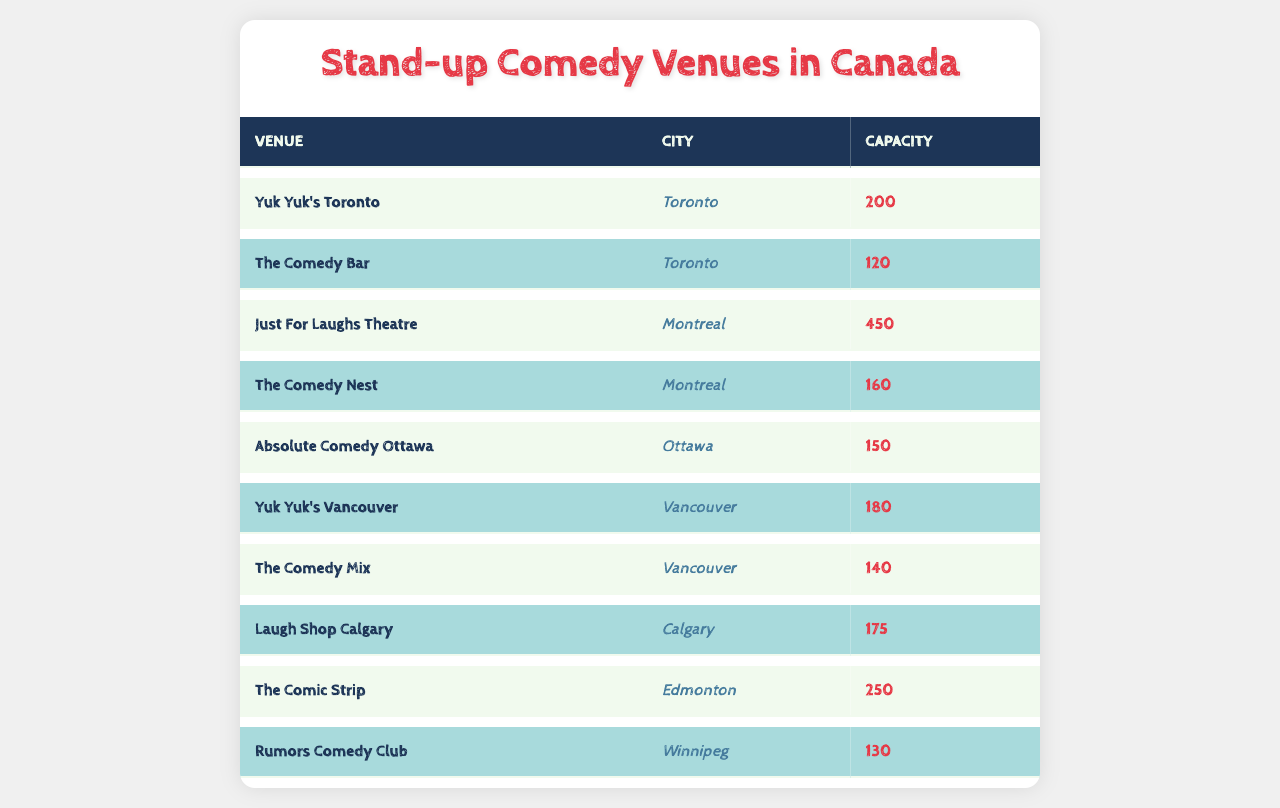What is the capacity of Yuk Yuk's Toronto? The table lists Yuk Yuk's Toronto, where the corresponding capacity is directly provided as 200.
Answer: 200 How many venues are located in Montreal? The table shows two venues in Montreal: Just For Laughs Theatre and The Comedy Nest. Therefore, the total count is 2.
Answer: 2 Which venue has the largest capacity? By examining the capacities listed, Just For Laughs Theatre has the largest capacity at 450, which is greater than any other venue.
Answer: 450 Is the capacity of the Comedy Mix greater than 150? The capacity of the Comedy Mix is listed as 140, which is less than 150, making the statement false.
Answer: No What is the total capacity of all venues in Vancouver? The capacities for the Vancouver venues are Yuk Yuk's Vancouver (180) and The Comedy Mix (140). Adding these gives: 180 + 140 = 320.
Answer: 320 Which city has the venue with the least capacity? The venue with the least capacity is The Comedy Mix (140) located in Vancouver. Since we are comparing all venues, it identifies Vancouver as having the smallest venue.
Answer: Vancouver What is the average capacity of all venues in the table? To find the average, add the capacities of all venues (200 + 120 + 450 + 160 + 150 + 180 + 140 + 175 + 250 + 130 = 1955) and then divide by the number of venues (10). Thus, the average is 1955 / 10 = 195.5.
Answer: 195.5 Which venue is situated in Toronto and has a larger capacity than 100? From the table's entry for Toronto, Yuk Yuk's Toronto (200) and The Comedy Bar (120) are both over 100, which answers the question affirmatively for both venues.
Answer: Yuk Yuk's Toronto, The Comedy Bar What is the combined capacity of the venues in Calgary and Ottawa? The capacity of Laugh Shop Calgary is 175, and Absolute Comedy Ottawa is 150. Adding these together gives: 175 + 150 = 325.
Answer: 325 Are there any venues in Winnipeg that have a capacity of over 150? The only venue in Winnipeg listed is Rumors Comedy Club, which has a capacity of 130, making the statement false since it does not exceed 150.
Answer: No Which city has more venues, Toronto or Montreal? Toronto has 2 venues (Yuk Yuk's Toronto and The Comedy Bar), while Montreal also has 2 venues (Just For Laughs Theatre and The Comedy Nest). Since they are equal, the answer is no for one being more than the other.
Answer: Equal 